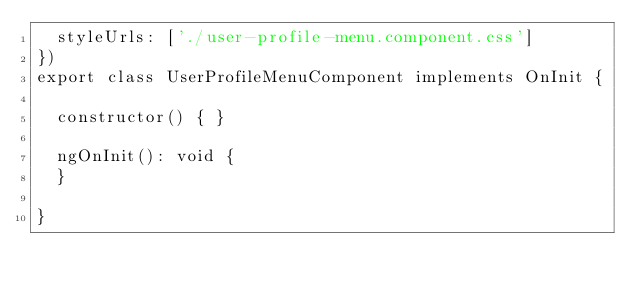<code> <loc_0><loc_0><loc_500><loc_500><_TypeScript_>  styleUrls: ['./user-profile-menu.component.css']
})
export class UserProfileMenuComponent implements OnInit {

  constructor() { }

  ngOnInit(): void {
  }

}
</code> 